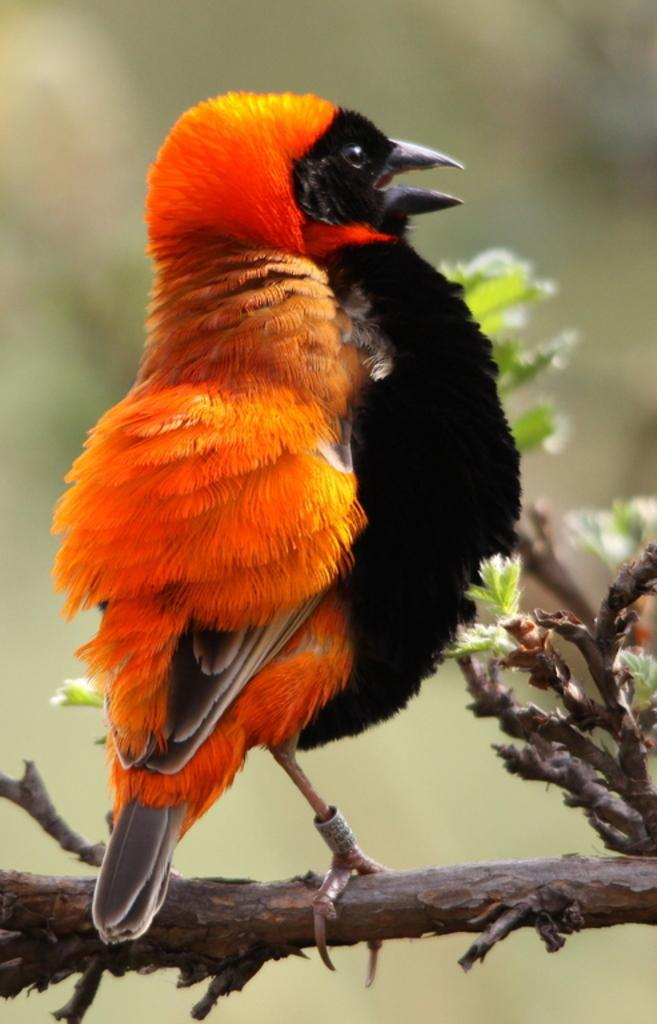What type of animal can be seen in the image? There is a bird in the image. Where is the bird located in relation to the image? The bird is in the foreground area of the image. What is the bird standing on in the image? The bird is on a stem in the image. What type of powder is visible on the bird's wings in the image? There is no powder visible on the bird's wings in the image. 